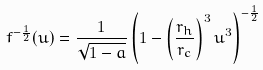Convert formula to latex. <formula><loc_0><loc_0><loc_500><loc_500>f ^ { - \frac { 1 } { 2 } } ( u ) = \frac { 1 } { \sqrt { 1 - a } } \left ( 1 - \left ( \frac { r _ { h } } { r _ { c } } \right ) ^ { 3 } u ^ { 3 } \right ) ^ { - \frac { 1 } { 2 } }</formula> 